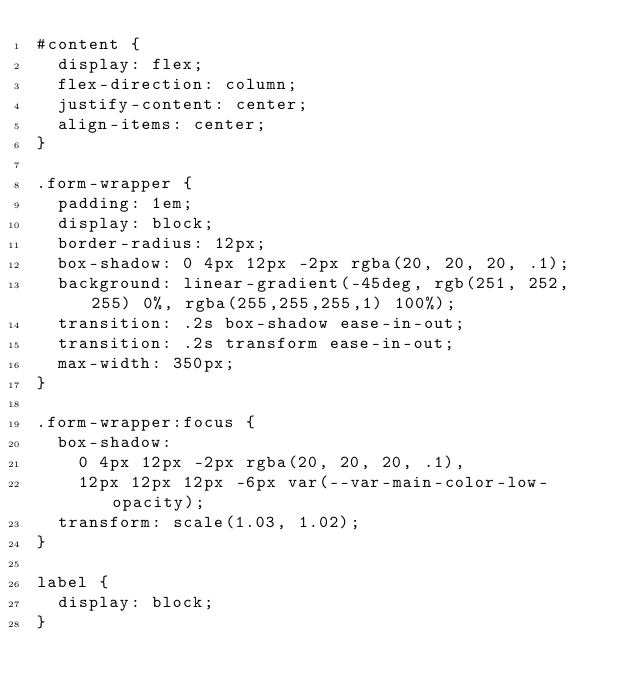<code> <loc_0><loc_0><loc_500><loc_500><_CSS_>#content {
  display: flex;
  flex-direction: column;
  justify-content: center;
  align-items: center;
}

.form-wrapper {
  padding: 1em;
  display: block;
  border-radius: 12px;
  box-shadow: 0 4px 12px -2px rgba(20, 20, 20, .1);
  background: linear-gradient(-45deg, rgb(251, 252, 255) 0%, rgba(255,255,255,1) 100%);
  transition: .2s box-shadow ease-in-out;
  transition: .2s transform ease-in-out;
  max-width: 350px;
}

.form-wrapper:focus {
  box-shadow: 
    0 4px 12px -2px rgba(20, 20, 20, .1),
    12px 12px 12px -6px var(--var-main-color-low-opacity);
  transform: scale(1.03, 1.02);
}

label {
  display: block;
}</code> 